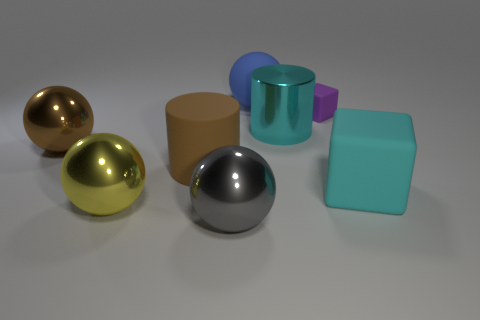Subtract all big brown shiny balls. How many balls are left? 3 Add 1 tiny purple rubber cylinders. How many objects exist? 9 Subtract all yellow balls. How many balls are left? 3 Subtract all blocks. How many objects are left? 6 Subtract all green spheres. Subtract all yellow blocks. How many spheres are left? 4 Add 7 large gray balls. How many large gray balls are left? 8 Add 8 matte cubes. How many matte cubes exist? 10 Subtract 1 cyan cubes. How many objects are left? 7 Subtract all large brown rubber things. Subtract all big rubber spheres. How many objects are left? 6 